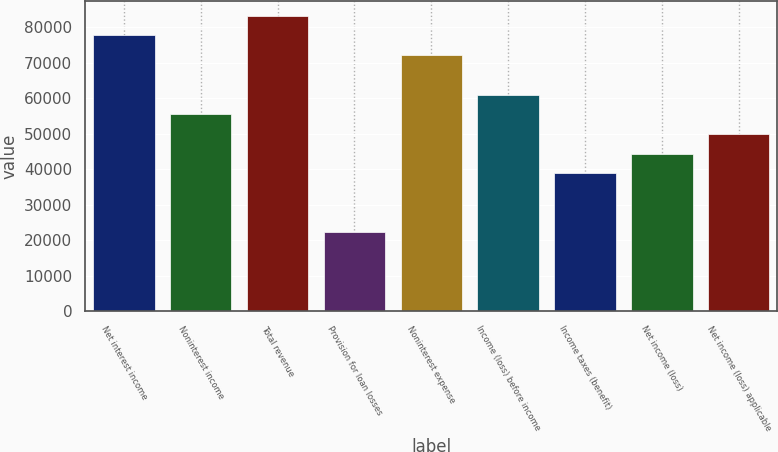Convert chart. <chart><loc_0><loc_0><loc_500><loc_500><bar_chart><fcel>Net interest income<fcel>Noninterest income<fcel>Total revenue<fcel>Provision for loan losses<fcel>Noninterest expense<fcel>Income (loss) before income<fcel>Income taxes (benefit)<fcel>Net income (loss)<fcel>Net income (loss) applicable<nl><fcel>77716.8<fcel>55512<fcel>83268<fcel>22204.8<fcel>72165.6<fcel>61063.2<fcel>38858.4<fcel>44409.6<fcel>49960.8<nl></chart> 